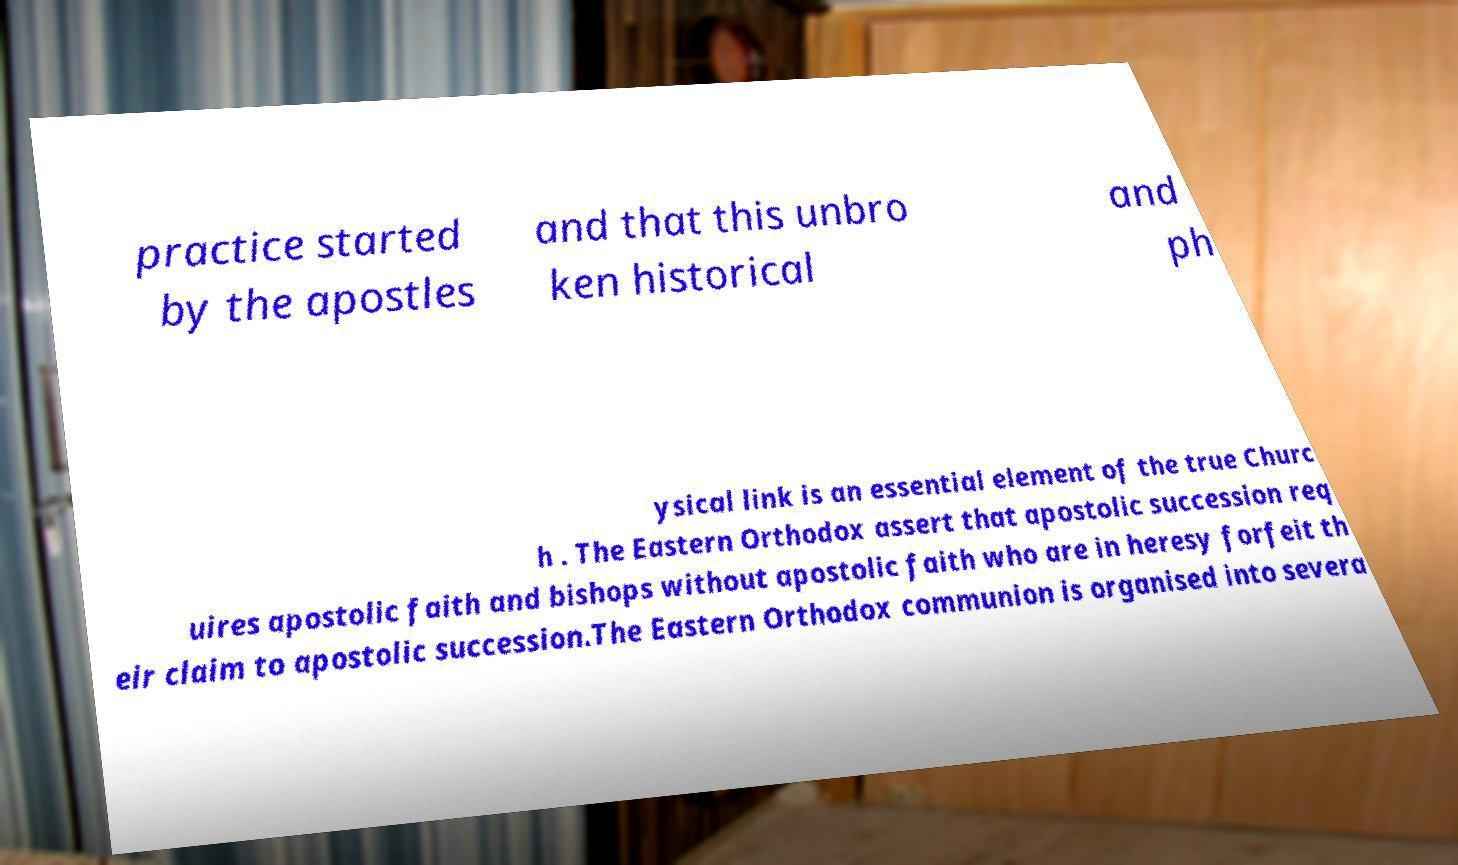Please identify and transcribe the text found in this image. practice started by the apostles and that this unbro ken historical and ph ysical link is an essential element of the true Churc h . The Eastern Orthodox assert that apostolic succession req uires apostolic faith and bishops without apostolic faith who are in heresy forfeit th eir claim to apostolic succession.The Eastern Orthodox communion is organised into severa 